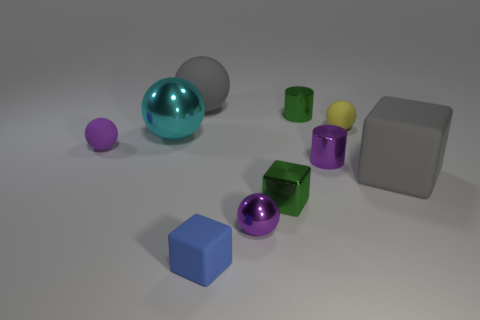Do the blue block that is on the left side of the tiny metallic ball and the small green thing behind the gray rubber cube have the same material?
Provide a short and direct response. No. Is there any other thing that has the same shape as the tiny blue thing?
Provide a short and direct response. Yes. Is the large cyan ball made of the same material as the gray thing on the left side of the tiny shiny cube?
Provide a short and direct response. No. There is a small ball in front of the cylinder in front of the small rubber object that is right of the green metal cylinder; what color is it?
Offer a terse response. Purple. The yellow object that is the same size as the green block is what shape?
Keep it short and to the point. Sphere. Is there anything else that is the same size as the purple matte sphere?
Provide a short and direct response. Yes. There is a ball in front of the small green metallic block; does it have the same size as the matte ball right of the small blue rubber thing?
Ensure brevity in your answer.  Yes. What size is the cylinder that is in front of the green shiny cylinder?
Offer a very short reply. Small. What is the material of the thing that is the same color as the shiny cube?
Your response must be concise. Metal. The shiny cube that is the same size as the yellow rubber sphere is what color?
Your answer should be compact. Green. 